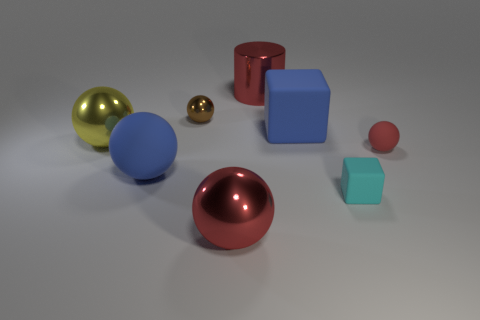Subtract all large red balls. How many balls are left? 4 Add 2 tiny brown metal things. How many objects exist? 10 Subtract 3 spheres. How many spheres are left? 2 Subtract all red balls. How many balls are left? 3 Add 4 tiny red matte balls. How many tiny red matte balls exist? 5 Subtract 0 purple cylinders. How many objects are left? 8 Subtract all cylinders. How many objects are left? 7 Subtract all green cylinders. Subtract all purple cubes. How many cylinders are left? 1 Subtract all green cylinders. How many brown balls are left? 1 Subtract all small gray rubber things. Subtract all big matte spheres. How many objects are left? 7 